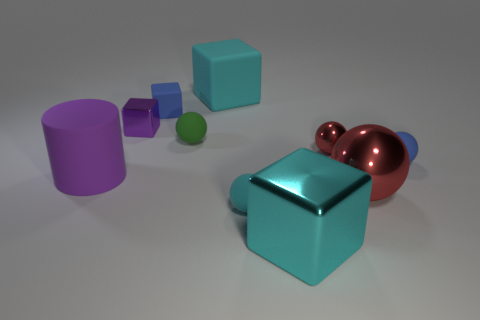Subtract all big red spheres. How many spheres are left? 4 Subtract all blue balls. How many balls are left? 4 Subtract 1 blocks. How many blocks are left? 3 Subtract all gray balls. Subtract all cyan cylinders. How many balls are left? 5 Subtract all cylinders. How many objects are left? 9 Add 6 small yellow metal spheres. How many small yellow metal spheres exist? 6 Subtract 1 blue balls. How many objects are left? 9 Subtract all large purple matte cylinders. Subtract all tiny cubes. How many objects are left? 7 Add 4 cyan balls. How many cyan balls are left? 5 